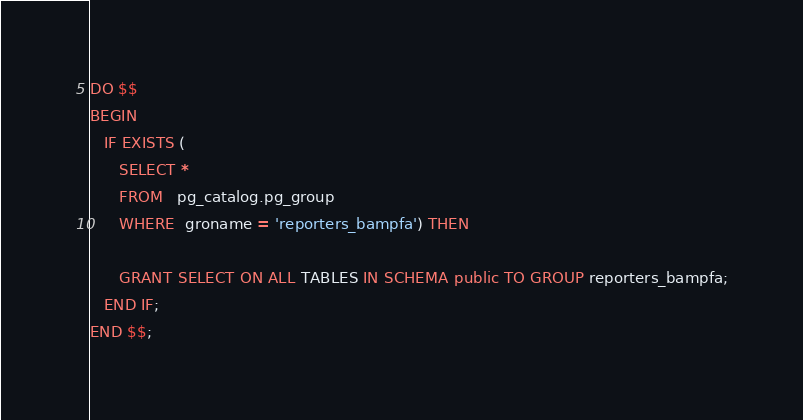<code> <loc_0><loc_0><loc_500><loc_500><_SQL_>DO $$
BEGIN
   IF EXISTS (
      SELECT *
      FROM   pg_catalog.pg_group
      WHERE  groname = 'reporters_bampfa') THEN

      GRANT SELECT ON ALL TABLES IN SCHEMA public TO GROUP reporters_bampfa;
   END IF;
END $$;
</code> 